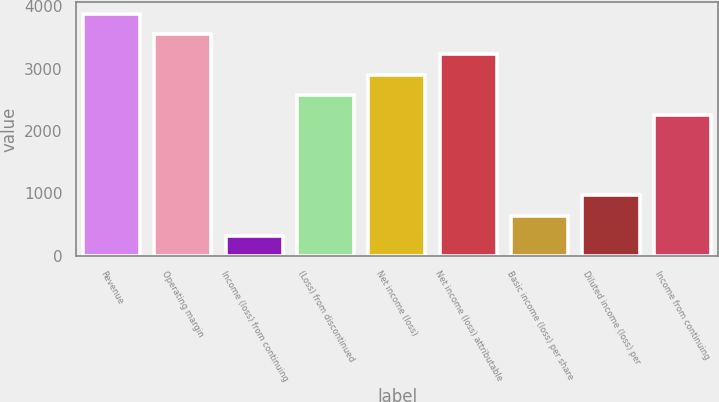Convert chart. <chart><loc_0><loc_0><loc_500><loc_500><bar_chart><fcel>Revenue<fcel>Operating margin<fcel>Income (loss) from continuing<fcel>(Loss) from discontinued<fcel>Net income (loss)<fcel>Net income (loss) attributable<fcel>Basic income (loss) per share<fcel>Diluted income (loss) per<fcel>Income from continuing<nl><fcel>3874.81<fcel>3551.91<fcel>322.91<fcel>2583.21<fcel>2906.11<fcel>3229.01<fcel>645.81<fcel>968.71<fcel>2260.31<nl></chart> 